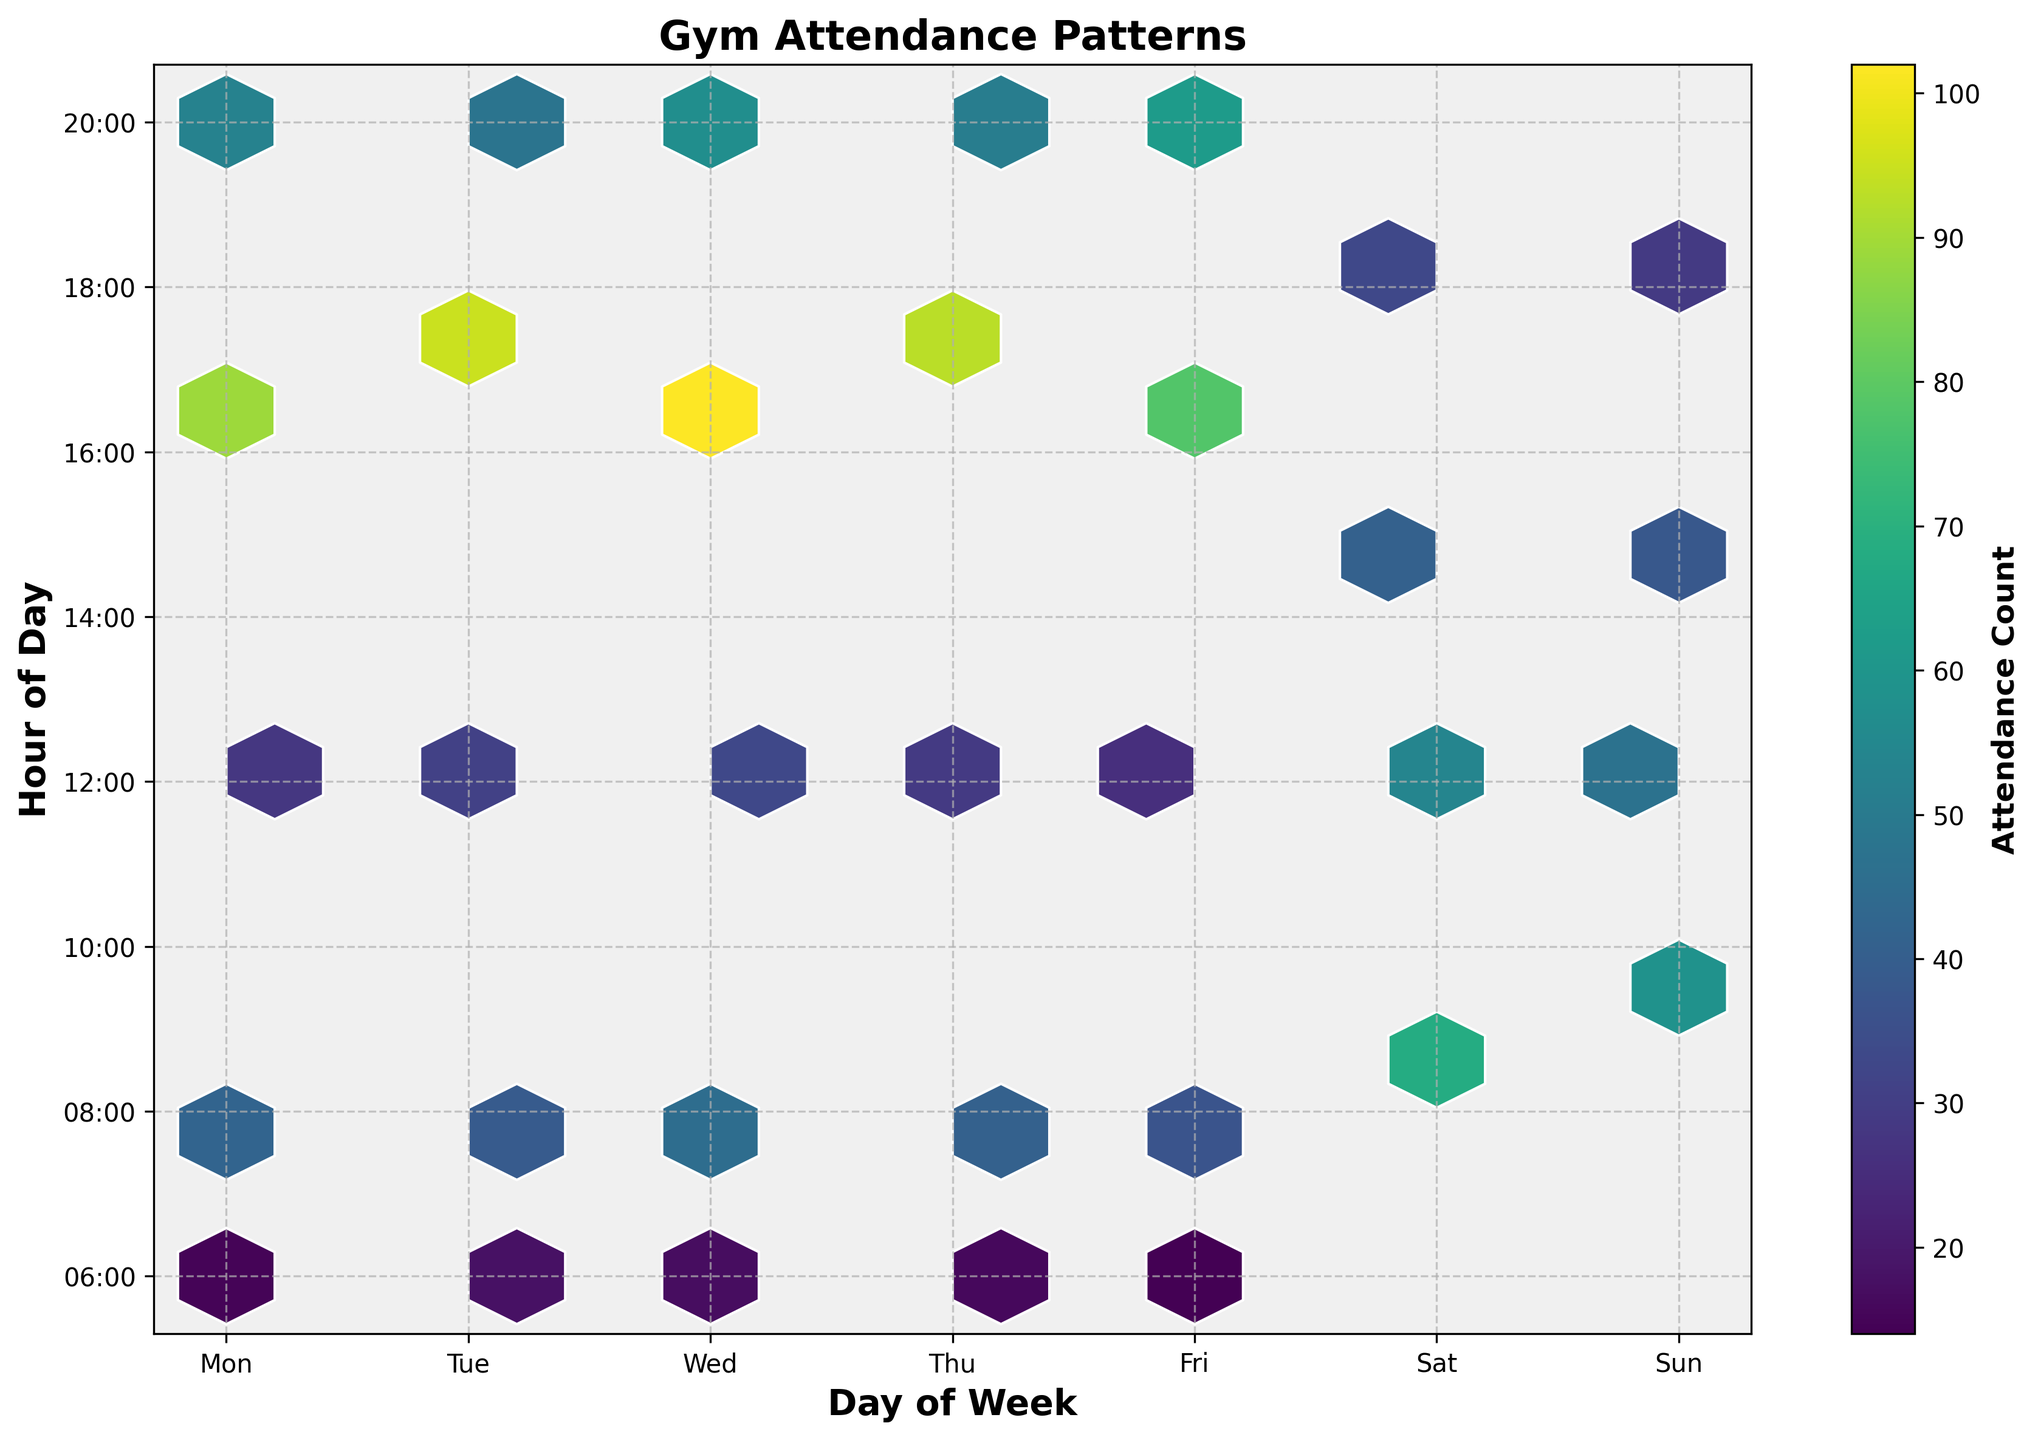What's the title of the plot? The title of the plot is displayed at the top of the figure. Titles are often used to provide a brief description of the visualized data.
Answer: Gym Attendance Patterns What days of the week does the gym see the highest attendance count at 17:00? By looking at the vertical lines corresponding to 17:00 on the hour of day axis, we can observe which days have the highest color intensity in the hexagonal bins. Days with more intense colors indicate higher attendance counts at that hour.
Answer: Tuesday and Wednesday Which hour of the day sees the most varied attendance patterns throughout the week? To determine the hour with the most varied attendance, look for the time slot with the widest range of color intensities across different days. This variation suggests fluctuating attendance patterns.
Answer: 17:00 On which day does the gym have the least attendance around 6:00? Identify the hexagonal bin corresponding to 6:00 and compare the color intensity on each day of the week. The day with the least intense color represents the lowest attendance.
Answer: Friday How does the gym attendance at 12:00 on weekends compare to weekdays? Check the color intensity of the hexagonal bins at 12:00 on Saturday and Sunday and compare them to the bins at the same hour from Monday to Friday. This will indicate differences in attendance.
Answer: Higher on weekends What patterns do you observe in gym attendance at 20:00? Look at the bins corresponding to 20:00 across the entire week to identify general trends, such as whether attendance is higher or lower on specific days.
Answer: Higher in the first half of the week Which day has the highest overall attendance count throughout the day? To find this, visually estimate which day's column of hexagonal bins has the most intense colors throughout the hours, indicating higher overall attendance.
Answer: Wednesday What is the attendance count range for Saturday between 9:00 and 18:00? Look at the color intensities of bins from 9:00 to 18:00 on Saturday. The colors (mapped from light to dark) indicate low to high attendance counts based on the displayed color scale.
Answer: Approximately 33 to 68 Where are the peak attendance periods on Sunday? Visually identify the hexagonal bins with the darkest colors on Sunday. These represent the hours with the highest concentration of gym attendees.
Answer: 9:00 and 12:00 Which day has consistently low attendance before 8:00? Examine the colors of bins from 6:00 to 8:00 across different days. The day with the lightest color bins in this range indicates consistently low attendance.
Answer: Friday 